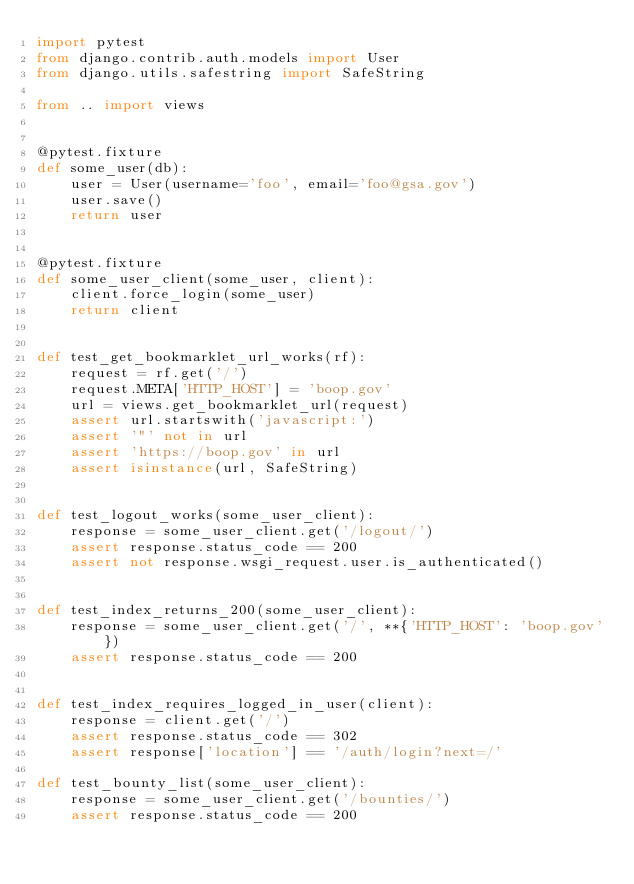<code> <loc_0><loc_0><loc_500><loc_500><_Python_>import pytest
from django.contrib.auth.models import User
from django.utils.safestring import SafeString

from .. import views


@pytest.fixture
def some_user(db):
    user = User(username='foo', email='foo@gsa.gov')
    user.save()
    return user


@pytest.fixture
def some_user_client(some_user, client):
    client.force_login(some_user)
    return client


def test_get_bookmarklet_url_works(rf):
    request = rf.get('/')
    request.META['HTTP_HOST'] = 'boop.gov'
    url = views.get_bookmarklet_url(request)
    assert url.startswith('javascript:')
    assert '"' not in url
    assert 'https://boop.gov' in url
    assert isinstance(url, SafeString)


def test_logout_works(some_user_client):
    response = some_user_client.get('/logout/')
    assert response.status_code == 200
    assert not response.wsgi_request.user.is_authenticated()


def test_index_returns_200(some_user_client):
    response = some_user_client.get('/', **{'HTTP_HOST': 'boop.gov'})
    assert response.status_code == 200


def test_index_requires_logged_in_user(client):
    response = client.get('/')
    assert response.status_code == 302
    assert response['location'] == '/auth/login?next=/'

def test_bounty_list(some_user_client):
    response = some_user_client.get('/bounties/')
    assert response.status_code == 200
</code> 